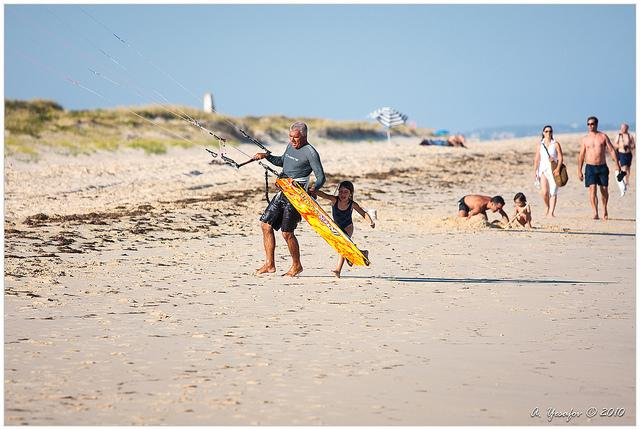What is the man helping the young woman with in the sand? Please explain your reasoning. build sandcastle. He is playing in the sand building things with her. 